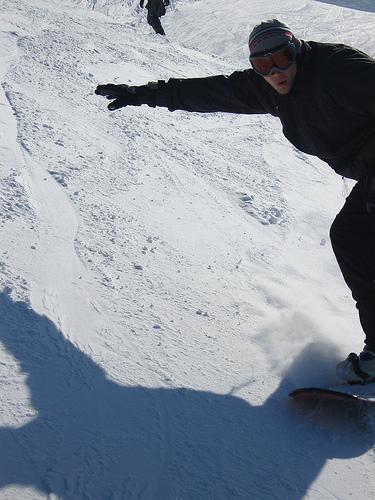How many people are there?
Give a very brief answer. 2. 